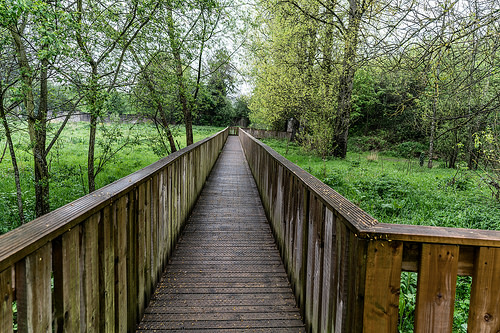<image>
Is there a sky behind the tree? Yes. From this viewpoint, the sky is positioned behind the tree, with the tree partially or fully occluding the sky. Is the bridge next to the grass? No. The bridge is not positioned next to the grass. They are located in different areas of the scene. Is the tree above the bridge? No. The tree is not positioned above the bridge. The vertical arrangement shows a different relationship. 